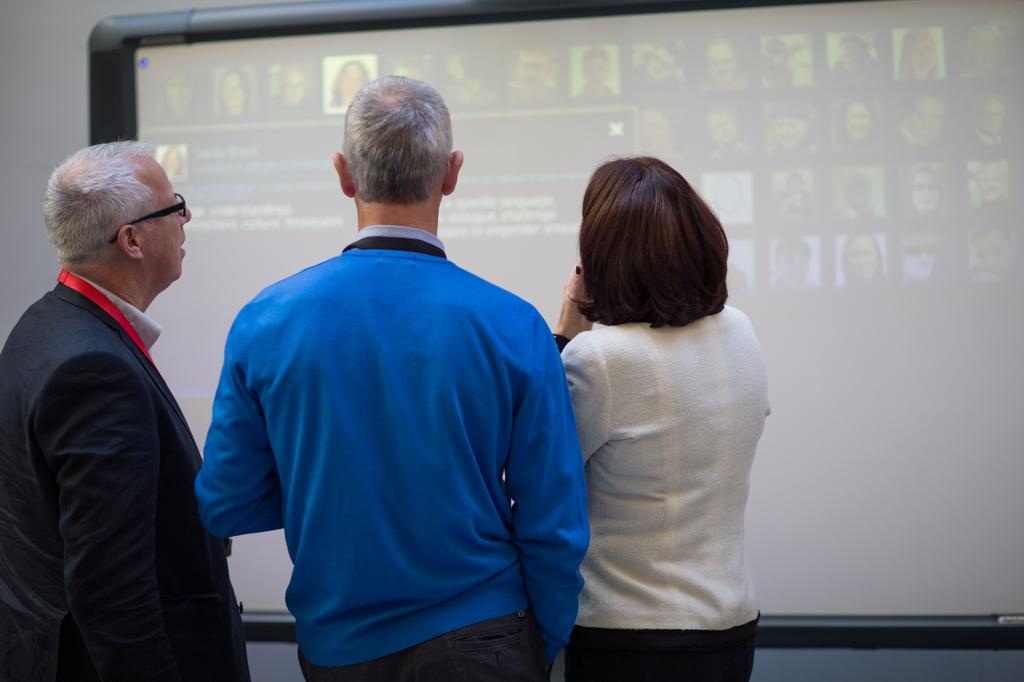How many people are in the foreground of the picture? There are three people standing in the foreground of the picture. What can be seen in the background of the picture? There is a projector screen in the background of the picture. What type of blood is visible on the mom's shirt in the image? There is no mom or blood present in the image; it only features three people standing in the foreground and a projector screen in the background. 